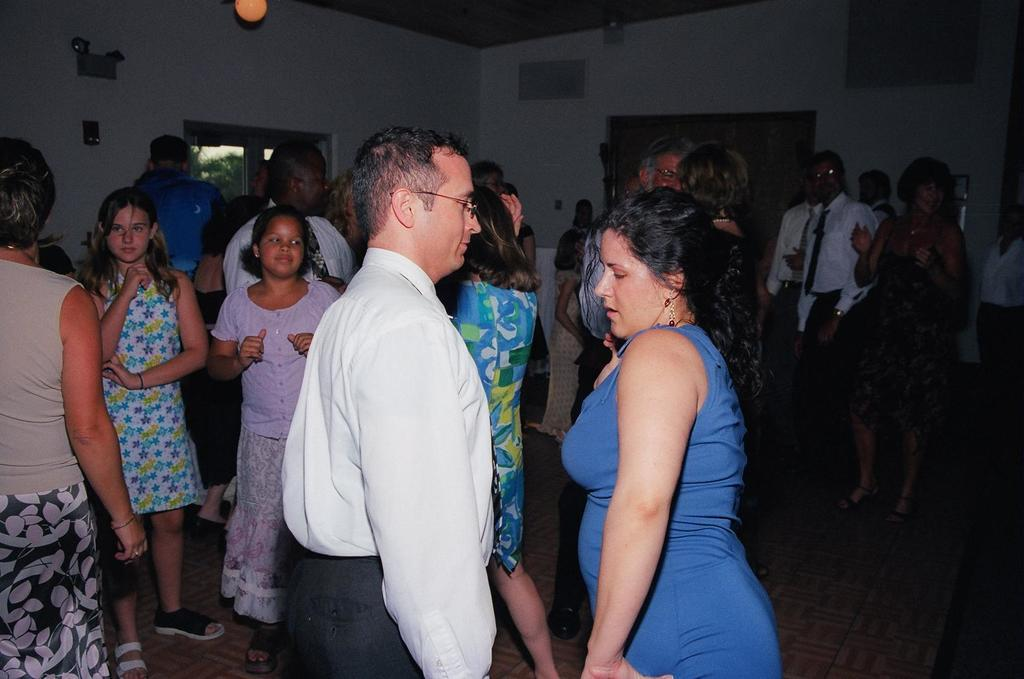What is the main subject of the image? The main subject of the image is people standing in the middle. What is located behind the people? There is a wall behind the people. What is visible at the top of the image? The top of the image contains a roof. Can you tell me which actor is standing in the middle of the image? There is no actor mentioned or visible in the image; it simply shows people standing. What type of vein can be seen running through the wall in the image? There is no vein visible in the image, as veins are not present in walls. 